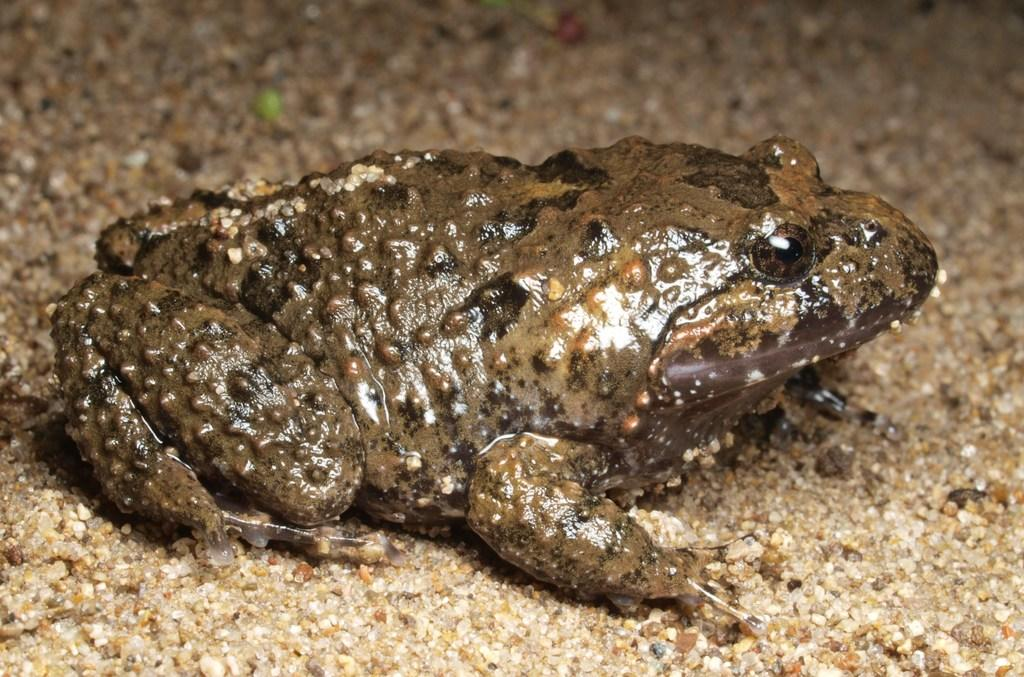What type of animal is in the image? There is a frog in the image. Where is the frog located in the image? The frog is on the floor. What is the frog's wish in the image? There is no indication in the image that the frog has a wish, as it is a still image and does not depict the frog's thoughts or desires. 